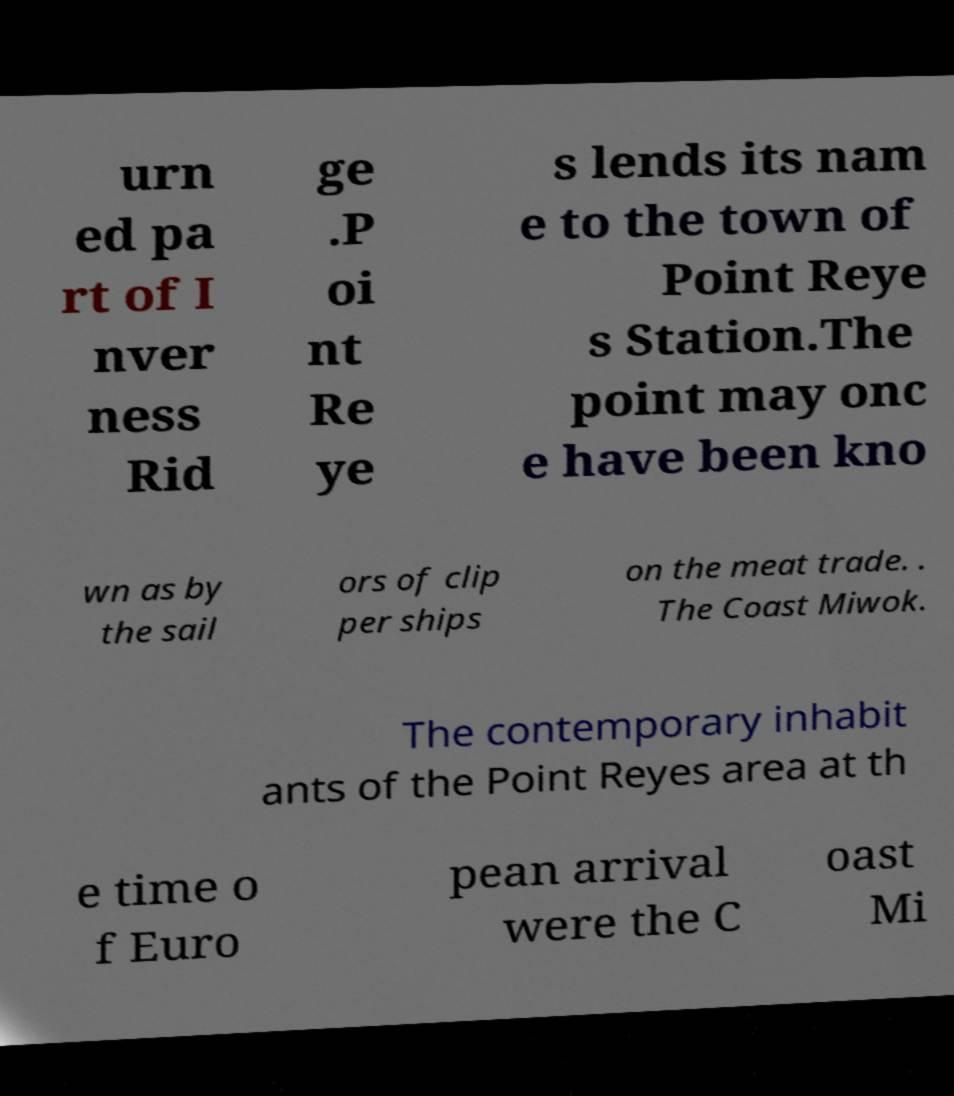I need the written content from this picture converted into text. Can you do that? urn ed pa rt of I nver ness Rid ge .P oi nt Re ye s lends its nam e to the town of Point Reye s Station.The point may onc e have been kno wn as by the sail ors of clip per ships on the meat trade. . The Coast Miwok. The contemporary inhabit ants of the Point Reyes area at th e time o f Euro pean arrival were the C oast Mi 